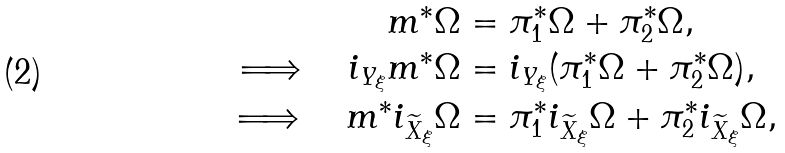Convert formula to latex. <formula><loc_0><loc_0><loc_500><loc_500>m ^ { * } \Omega & = \pi _ { 1 } ^ { * } \Omega + \pi _ { 2 } ^ { * } \Omega , \\ \Longrightarrow \quad i _ { Y _ { \xi } } m ^ { * } \Omega & = i _ { Y _ { \xi } } ( \pi _ { 1 } ^ { * } \Omega + \pi _ { 2 } ^ { * } \Omega ) , \\ \Longrightarrow \quad m ^ { * } i _ { \widetilde { X } _ { \xi } } \Omega & = \pi _ { 1 } ^ { * } i _ { \widetilde { X } _ { \xi } } \Omega + \pi _ { 2 } ^ { * } i _ { \widetilde { X } _ { \xi } } \Omega ,</formula> 